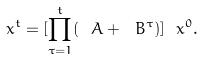<formula> <loc_0><loc_0><loc_500><loc_500>\ x ^ { t } = [ \prod _ { \tau = 1 } ^ { t } ( \ A + \ B ^ { \tau } ) ] \ x ^ { 0 } .</formula> 